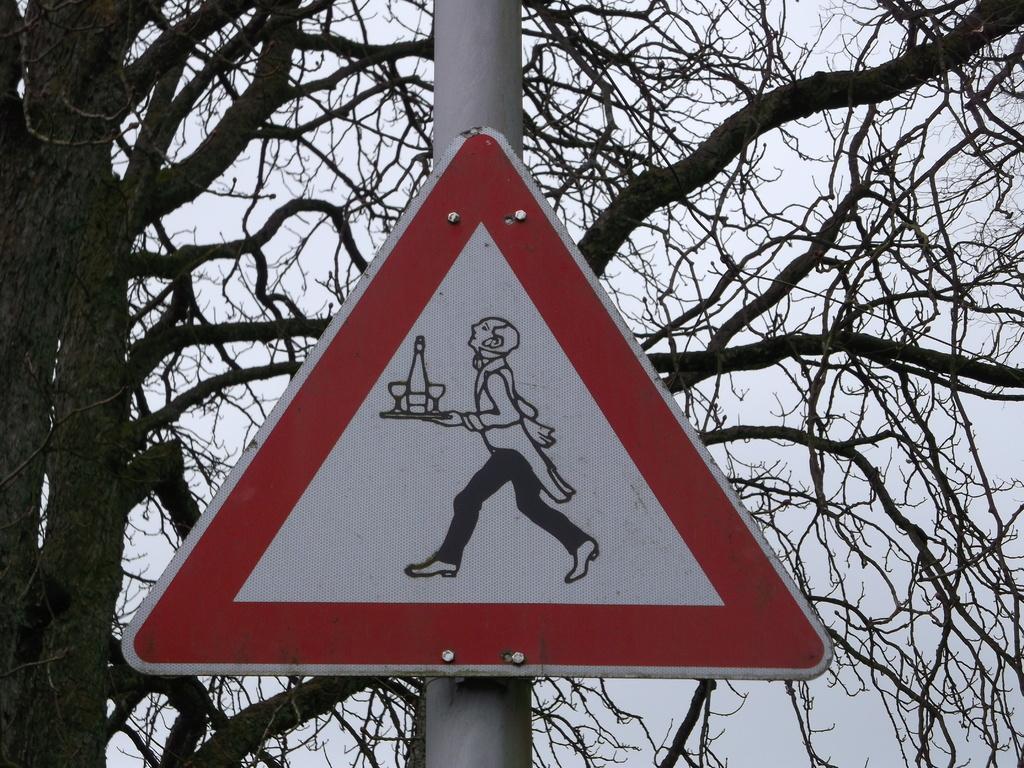Could you give a brief overview of what you see in this image? In the center of the image we can see a sign board attached to the pole. In the background we can see the tree. 